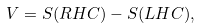Convert formula to latex. <formula><loc_0><loc_0><loc_500><loc_500>V = S ( R H C ) - S ( L H C ) ,</formula> 